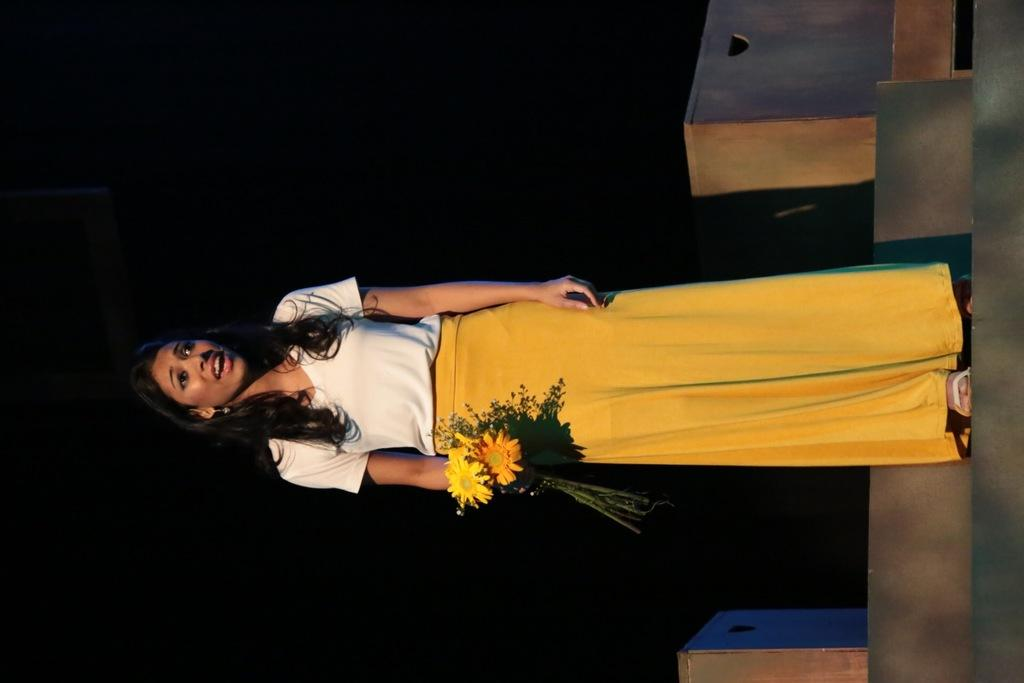Who is the main subject in the image? There is a lady in the center of the image. What is the lady holding in the image? The lady is holding flowers. Where is the lady standing in the image? The lady is standing on a staircase. What else can be seen in the image besides the lady? There are boxes in the image. What is the color of the background in the image? The background of the image is black in color. What is the lady arguing about with the boxes in the image? There is no argument present in the image; the lady is simply holding flowers and standing on a staircase. 